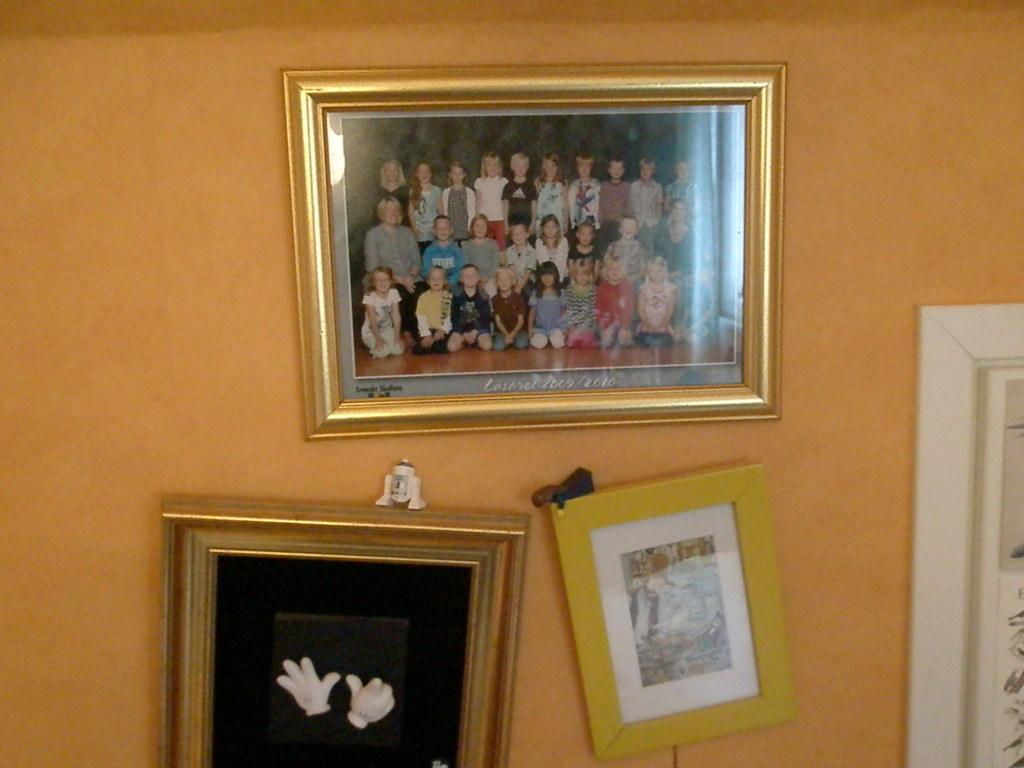What is attached to the wall in the image? There are frames attached to the wall in the image. Can you describe the location of the top frame? The top frame is at the top of the wall. What is depicted in the top frame? The top frame contains an image of children. What are the children in the image doing? Some children in the image are sitting on the floor, while others are standing. What type of sugar is being used to water the flowers in the image? There are no flowers or sugar present in the image; it only features frames with images of children. 